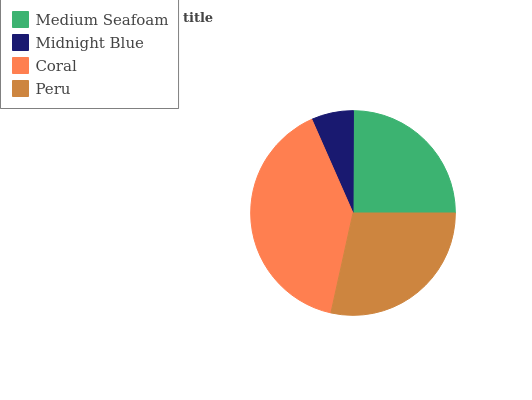Is Midnight Blue the minimum?
Answer yes or no. Yes. Is Coral the maximum?
Answer yes or no. Yes. Is Coral the minimum?
Answer yes or no. No. Is Midnight Blue the maximum?
Answer yes or no. No. Is Coral greater than Midnight Blue?
Answer yes or no. Yes. Is Midnight Blue less than Coral?
Answer yes or no. Yes. Is Midnight Blue greater than Coral?
Answer yes or no. No. Is Coral less than Midnight Blue?
Answer yes or no. No. Is Peru the high median?
Answer yes or no. Yes. Is Medium Seafoam the low median?
Answer yes or no. Yes. Is Midnight Blue the high median?
Answer yes or no. No. Is Midnight Blue the low median?
Answer yes or no. No. 